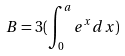<formula> <loc_0><loc_0><loc_500><loc_500>B = 3 ( \int _ { 0 } ^ { a } e ^ { x } d x )</formula> 